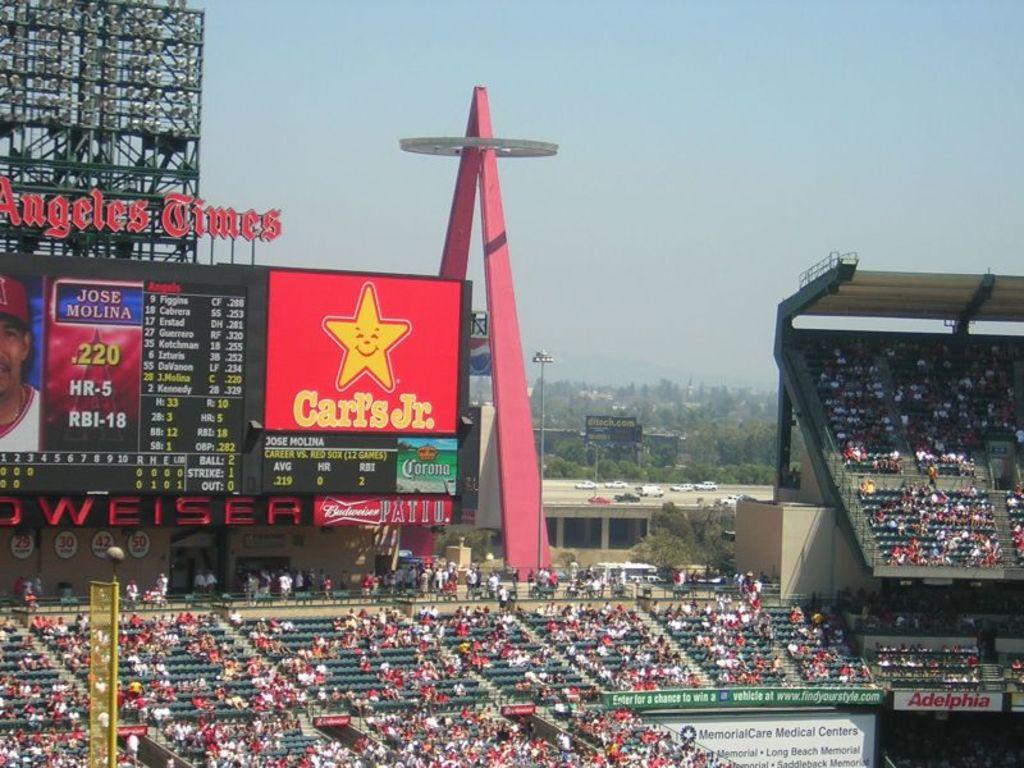What is the name of restaurant on the sign?
Your answer should be compact. Carl's jr. What player is on the display?
Your answer should be compact. Jose molina. 